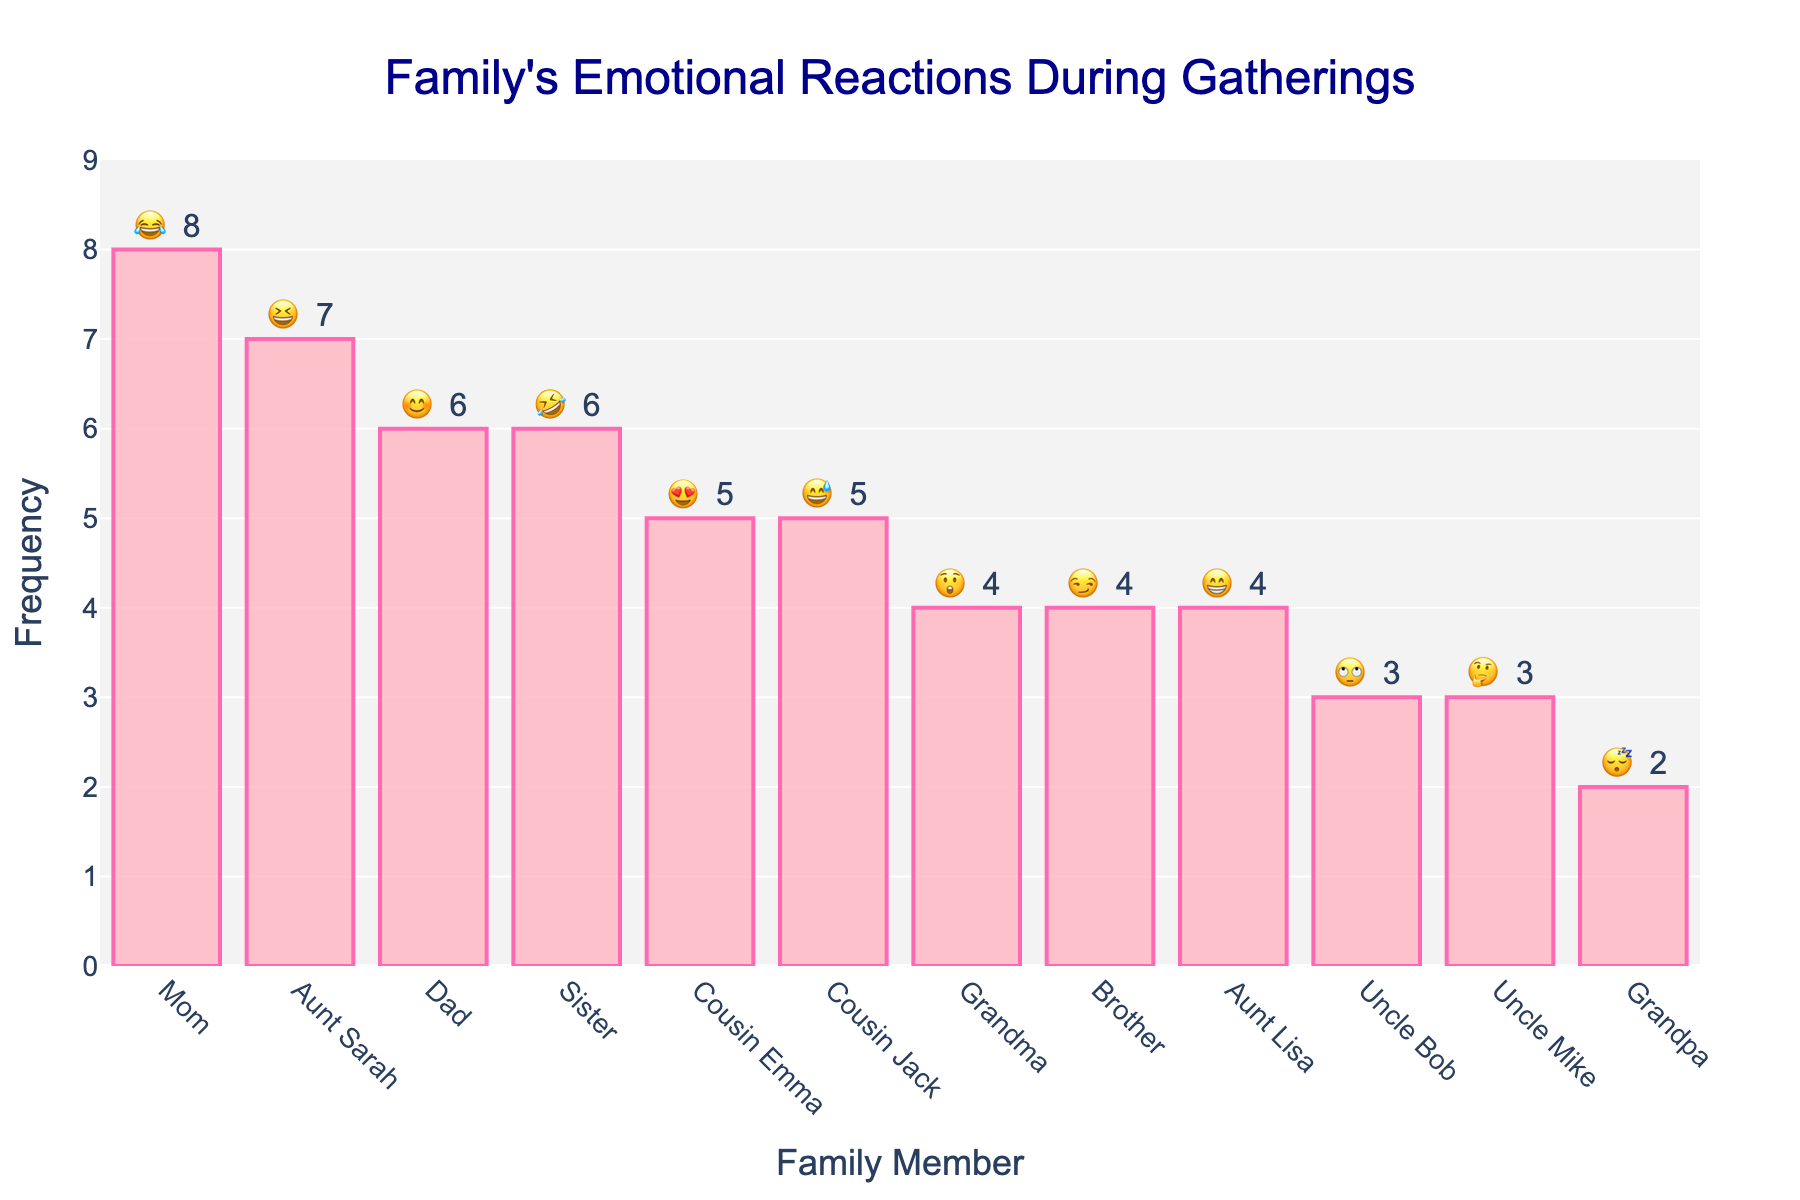what is the reaction with the highest frequency? The reaction with the highest frequency is indicated by the tallest bar. In this plot, the reaction with the highest frequency is Mom's reaction (😂) with a frequency of 8.
Answer: 😂 which family member has the lowest frequency of reaction, and what is it? By looking for the shortest bar, you can determine that Grandpa's reaction (😴) has the lowest frequency of 2.
Answer: Grandpa, 😴 how many family members show a reaction frequency of 4? Counting the bars with a frequency of 4, you find three family members: Grandma (😲), Brother (😏), and Aunt Lisa (😁).
Answer: 3 what is the combined frequency of Cousin Emma's and Cousin Jack's reactions? Cousin Emma's reaction (😍) has a frequency of 5, and Cousin Jack's reaction (😅) also has a frequency of 5. Combining these gives 5 + 5 = 10.
Answer: 10 does Aunt Sarah or Sister have a higher frequency of reaction, and by how much? Aunt Sarah's reaction (😆) has a frequency of 7, while Sister's reaction (🤣) has a frequency of 6. Aunt Sarah's frequency is higher by 1.
Answer: Aunt Sarah, by 1 which family members have a reaction frequency greater than or equal to 6? By identifying the bars with frequencies of 6 or higher, you find Mom (😂, 8), Aunt Sarah (😆, 7), Dad (😊, 6), and Sister (🤣, 6).
Answer: Mom, Aunt Sarah, Dad, Sister if you add the total frequencies of Uncle Bob, Uncle Mike, and Grandpa, what is the sum? Adding the frequencies of Uncle Bob (🙄, 3), Uncle Mike (🤔, 3), and Grandpa (😴, 2) gives 3 + 3 + 2 = 8.
Answer: 8 what is the average frequency of all family members' reactions? Sum all the frequencies: 8 (Mom) + 6 (Dad) + 4 (Grandma) + 3 (Uncle Bob) + 7 (Aunt Sarah) + 5 (Cousin Emma) + 4 (Brother) + 6 (Sister) + 2 (Grandpa) + 5 (Cousin Jack) + 4 (Aunt Lisa) + 3 (Uncle Mike) = 57. Dividing by the number of family members (12) gives 57 / 12 ≈ 4.75.
Answer: 4.75 